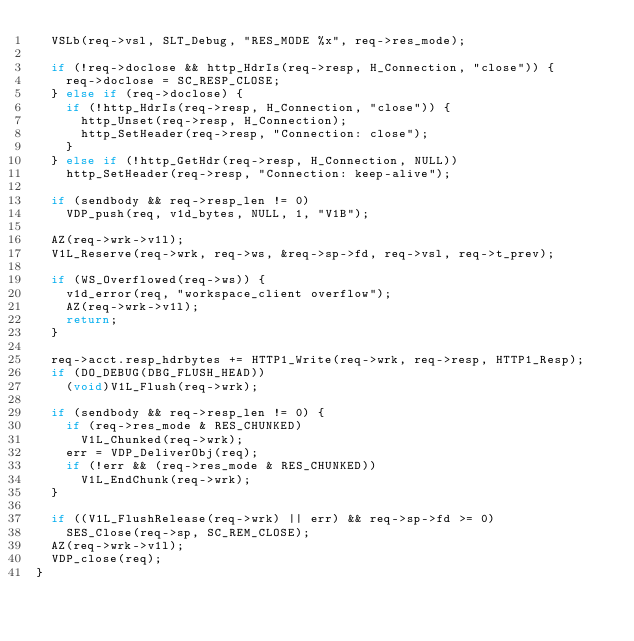<code> <loc_0><loc_0><loc_500><loc_500><_C_>	VSLb(req->vsl, SLT_Debug, "RES_MODE %x", req->res_mode);

	if (!req->doclose && http_HdrIs(req->resp, H_Connection, "close")) {
		req->doclose = SC_RESP_CLOSE;
	} else if (req->doclose) {
		if (!http_HdrIs(req->resp, H_Connection, "close")) {
			http_Unset(req->resp, H_Connection);
			http_SetHeader(req->resp, "Connection: close");
		}
	} else if (!http_GetHdr(req->resp, H_Connection, NULL))
		http_SetHeader(req->resp, "Connection: keep-alive");

	if (sendbody && req->resp_len != 0)
		VDP_push(req, v1d_bytes, NULL, 1, "V1B");

	AZ(req->wrk->v1l);
	V1L_Reserve(req->wrk, req->ws, &req->sp->fd, req->vsl, req->t_prev);

	if (WS_Overflowed(req->ws)) {
		v1d_error(req, "workspace_client overflow");
		AZ(req->wrk->v1l);
		return;
	}

	req->acct.resp_hdrbytes += HTTP1_Write(req->wrk, req->resp, HTTP1_Resp);
	if (DO_DEBUG(DBG_FLUSH_HEAD))
		(void)V1L_Flush(req->wrk);

	if (sendbody && req->resp_len != 0) {
		if (req->res_mode & RES_CHUNKED)
			V1L_Chunked(req->wrk);
		err = VDP_DeliverObj(req);
		if (!err && (req->res_mode & RES_CHUNKED))
			V1L_EndChunk(req->wrk);
	}

	if ((V1L_FlushRelease(req->wrk) || err) && req->sp->fd >= 0)
		SES_Close(req->sp, SC_REM_CLOSE);
	AZ(req->wrk->v1l);
	VDP_close(req);
}
</code> 